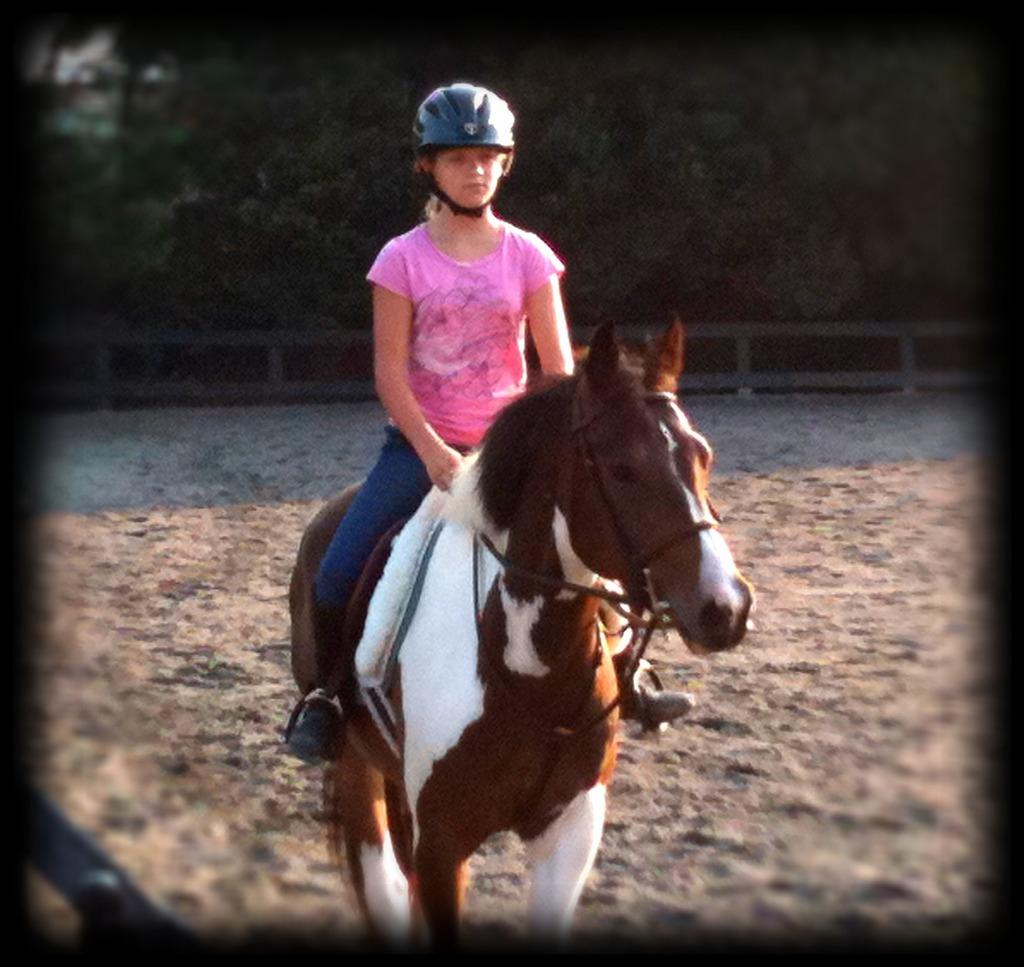What is the primary feature of the landscape in the image? There are many trees in the image. What type of structure can be seen in the image? There is a fencing in the image. What activity is the girl in the image engaged in? The girl is riding a horse in the image. Can you describe the object on the left side of the image? Unfortunately, the facts provided do not give any information about the object on the left side of the image. What type of board is the girl using to ride the horse in the image? There is no board present in the image; the girl is riding a horse without any additional equipment. 